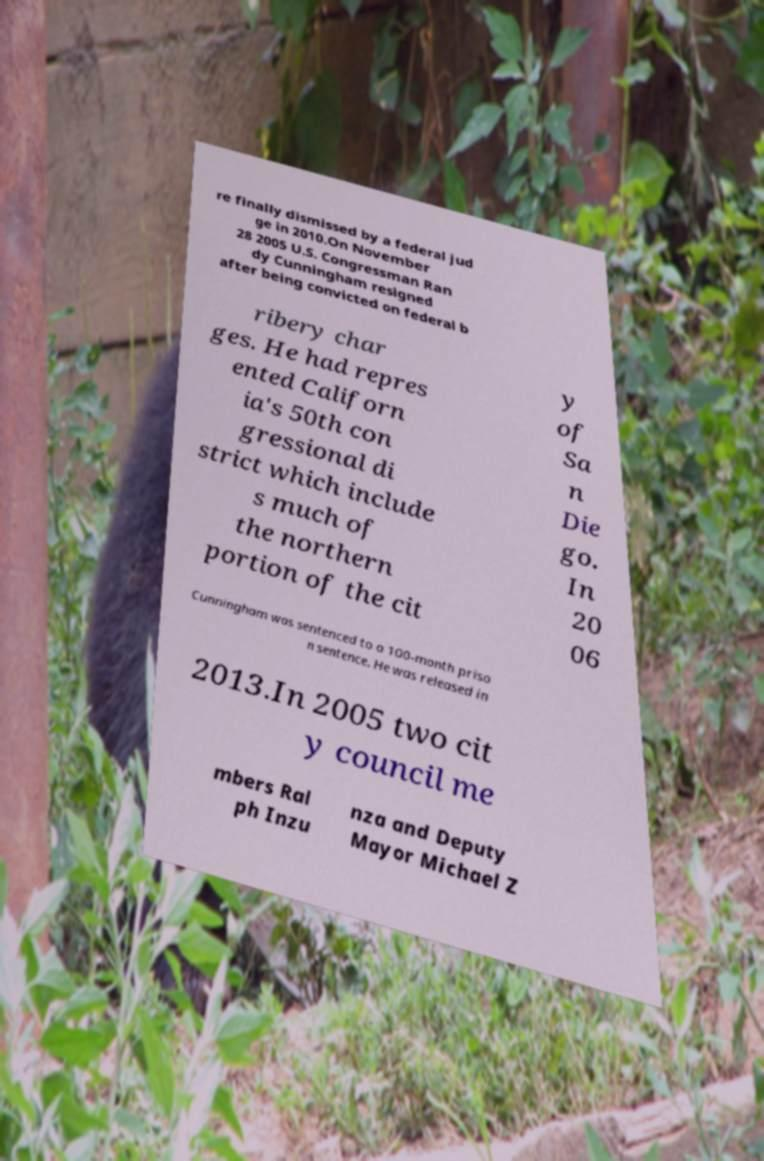Could you assist in decoding the text presented in this image and type it out clearly? re finally dismissed by a federal jud ge in 2010.On November 28 2005 U.S. Congressman Ran dy Cunningham resigned after being convicted on federal b ribery char ges. He had repres ented Californ ia's 50th con gressional di strict which include s much of the northern portion of the cit y of Sa n Die go. In 20 06 Cunningham was sentenced to a 100-month priso n sentence. He was released in 2013.In 2005 two cit y council me mbers Ral ph Inzu nza and Deputy Mayor Michael Z 